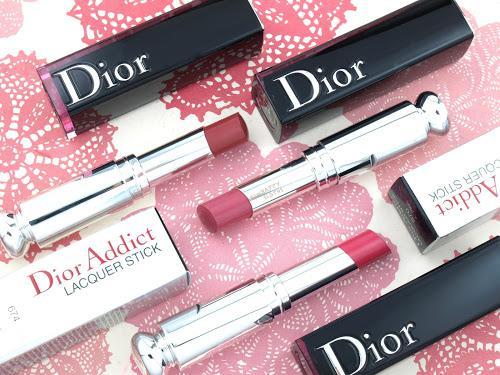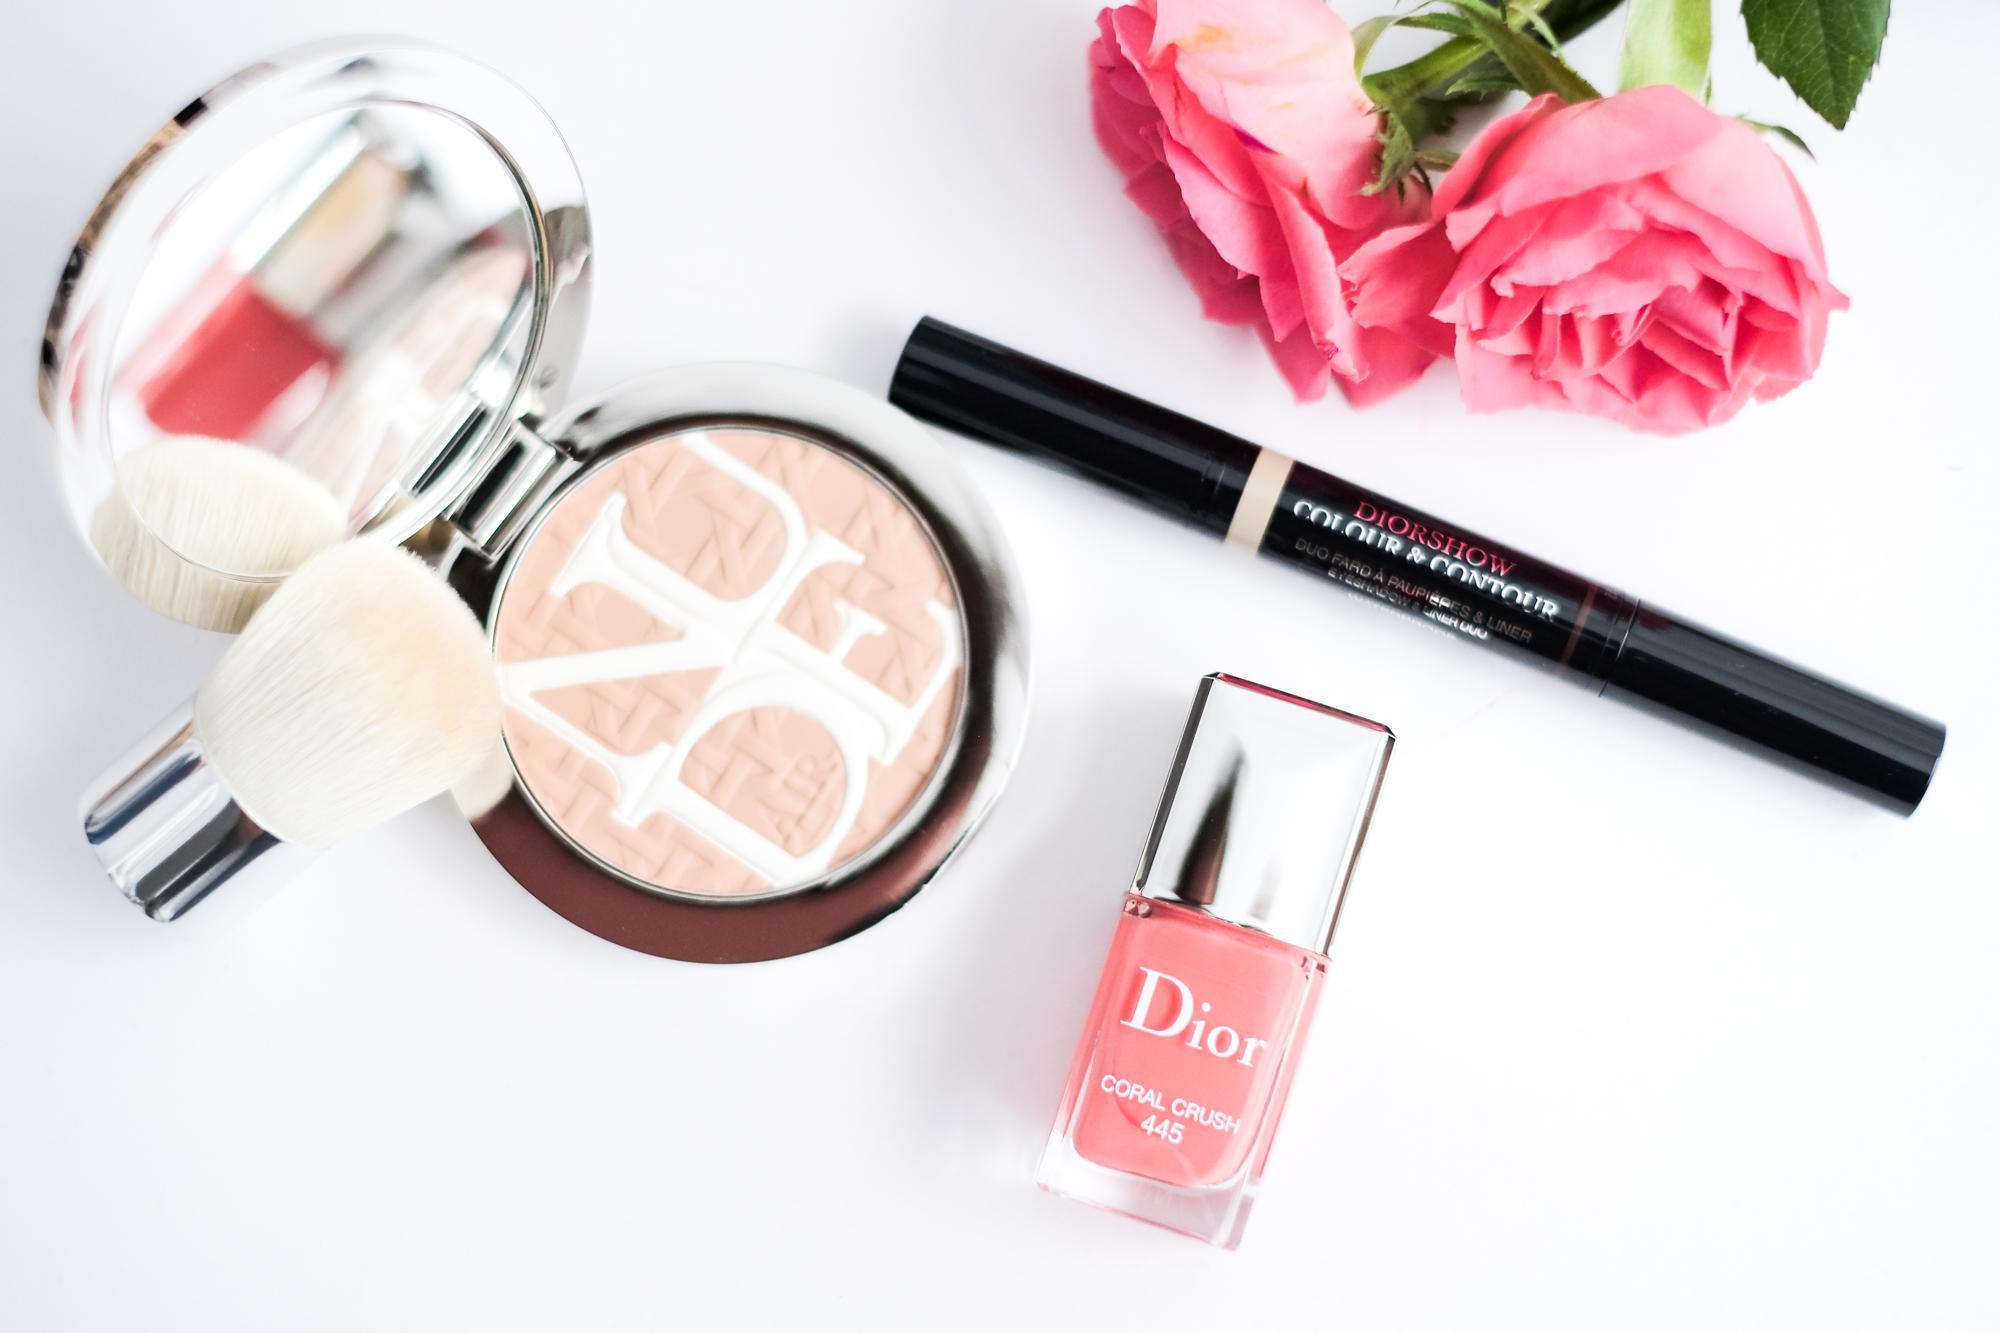The first image is the image on the left, the second image is the image on the right. Evaluate the accuracy of this statement regarding the images: "Each image includes an unlidded double-sided lip makeup with a marker-type tip on each end of a stick.". Is it true? Answer yes or no. No. The first image is the image on the left, the second image is the image on the right. For the images shown, is this caption "The makeup in the left image is photographed against a pure white background with no decoration on it." true? Answer yes or no. No. 